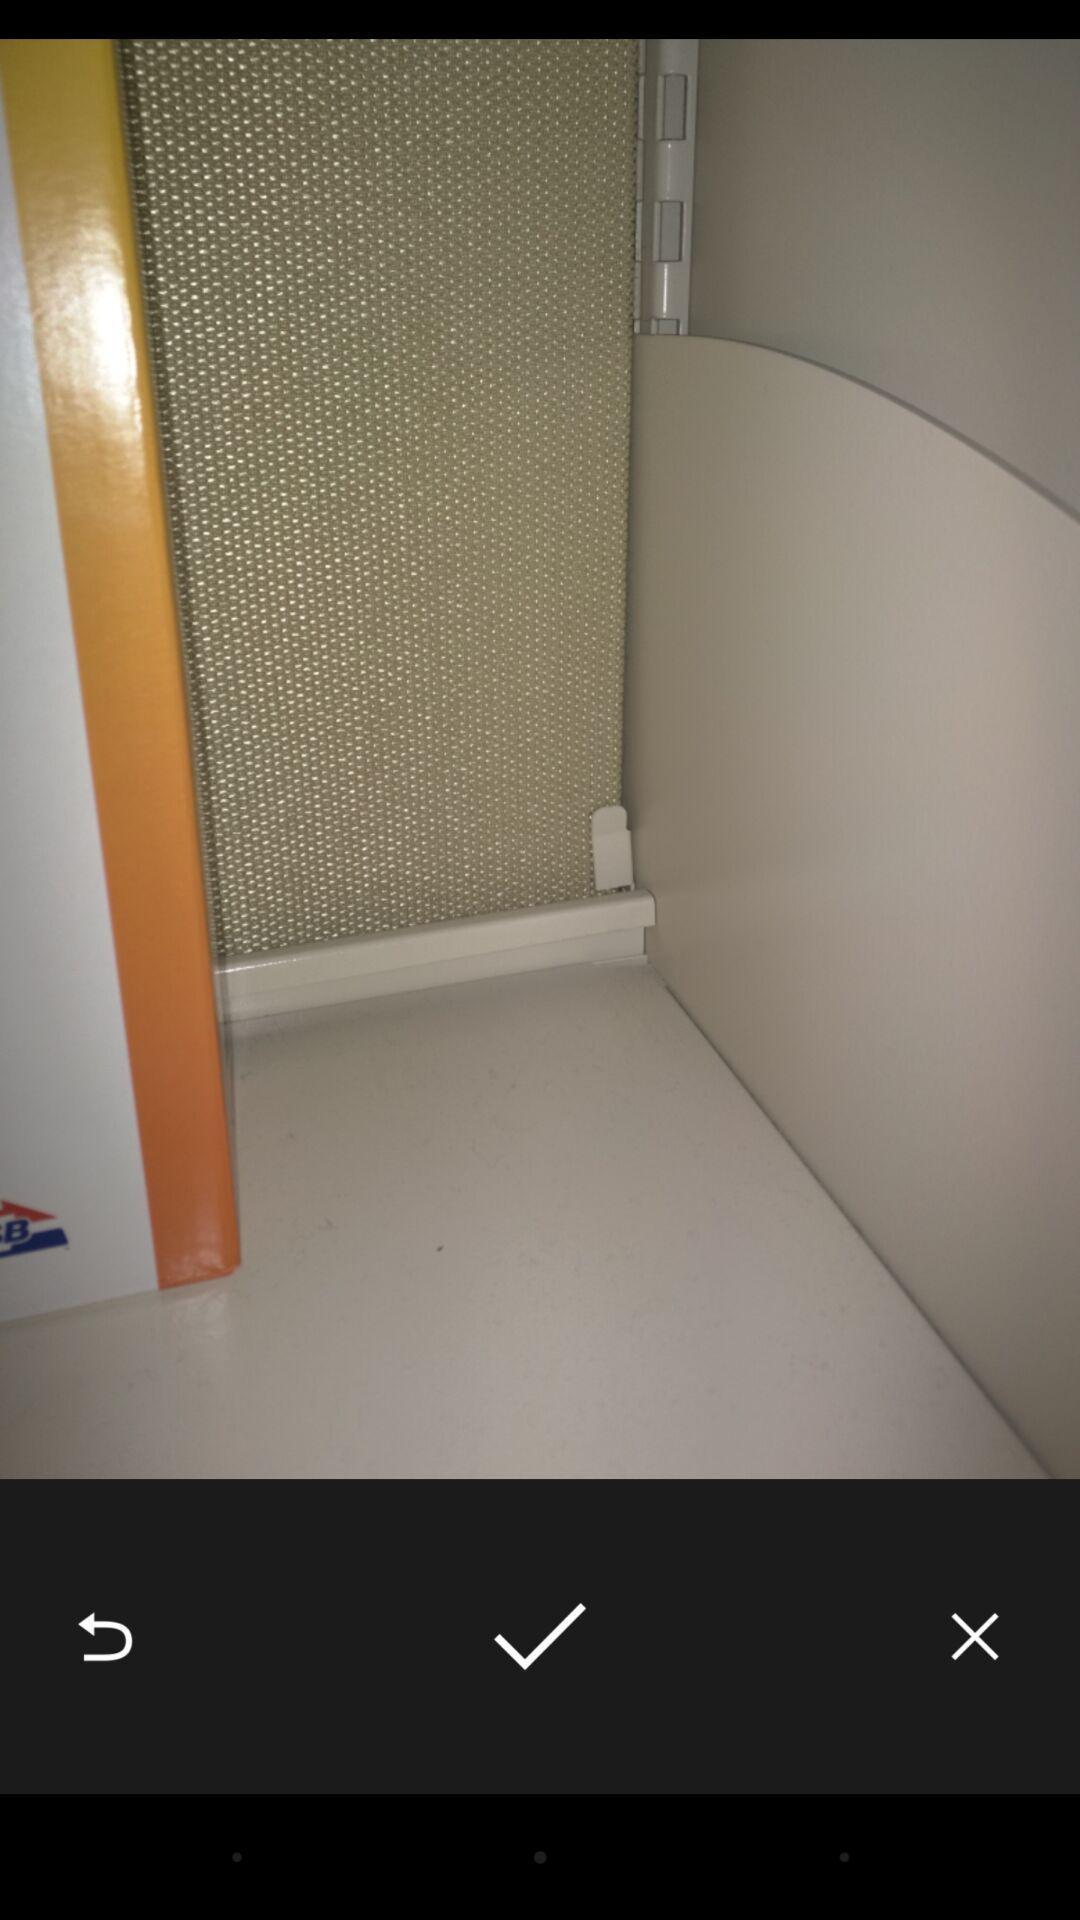Describe the key features of this screenshot. Page displaying photos with buttons. 